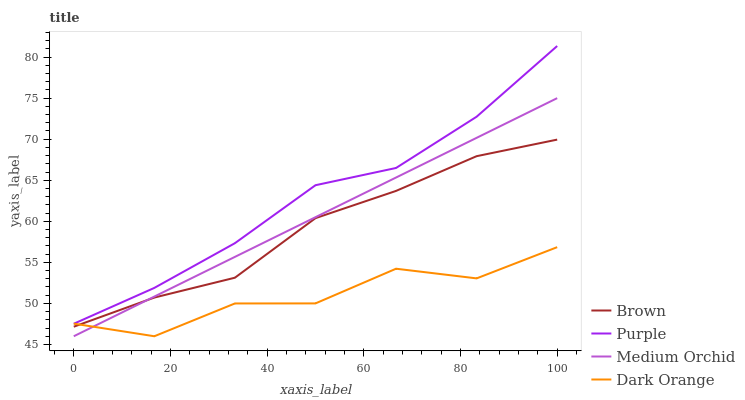Does Dark Orange have the minimum area under the curve?
Answer yes or no. Yes. Does Purple have the maximum area under the curve?
Answer yes or no. Yes. Does Brown have the minimum area under the curve?
Answer yes or no. No. Does Brown have the maximum area under the curve?
Answer yes or no. No. Is Medium Orchid the smoothest?
Answer yes or no. Yes. Is Dark Orange the roughest?
Answer yes or no. Yes. Is Brown the smoothest?
Answer yes or no. No. Is Brown the roughest?
Answer yes or no. No. Does Brown have the lowest value?
Answer yes or no. No. Does Purple have the highest value?
Answer yes or no. Yes. Does Brown have the highest value?
Answer yes or no. No. Is Brown less than Purple?
Answer yes or no. Yes. Is Purple greater than Brown?
Answer yes or no. Yes. Does Brown intersect Purple?
Answer yes or no. No. 